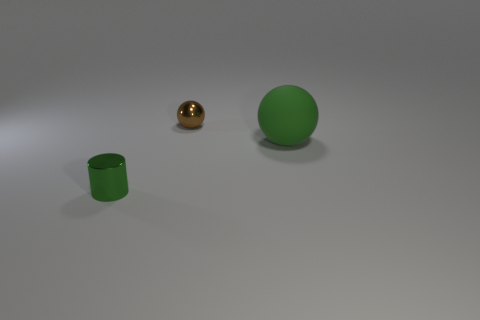Are there any other things that are made of the same material as the green sphere?
Make the answer very short. No. Are there any green shiny objects of the same size as the brown thing?
Offer a very short reply. Yes. How many objects are small shiny objects that are behind the small green metallic cylinder or green objects right of the green shiny cylinder?
Give a very brief answer. 2. What color is the tiny thing that is in front of the ball that is to the left of the big green thing?
Ensure brevity in your answer.  Green. The thing that is the same material as the tiny green cylinder is what color?
Provide a short and direct response. Brown. How many rubber spheres have the same color as the tiny metallic sphere?
Offer a terse response. 0. How many objects are either small purple rubber spheres or small brown shiny things?
Your answer should be very brief. 1. There is a green shiny object that is the same size as the shiny ball; what is its shape?
Provide a short and direct response. Cylinder. How many things are both to the right of the small cylinder and left of the large green thing?
Your response must be concise. 1. What is the green thing behind the shiny cylinder made of?
Provide a succinct answer. Rubber. 